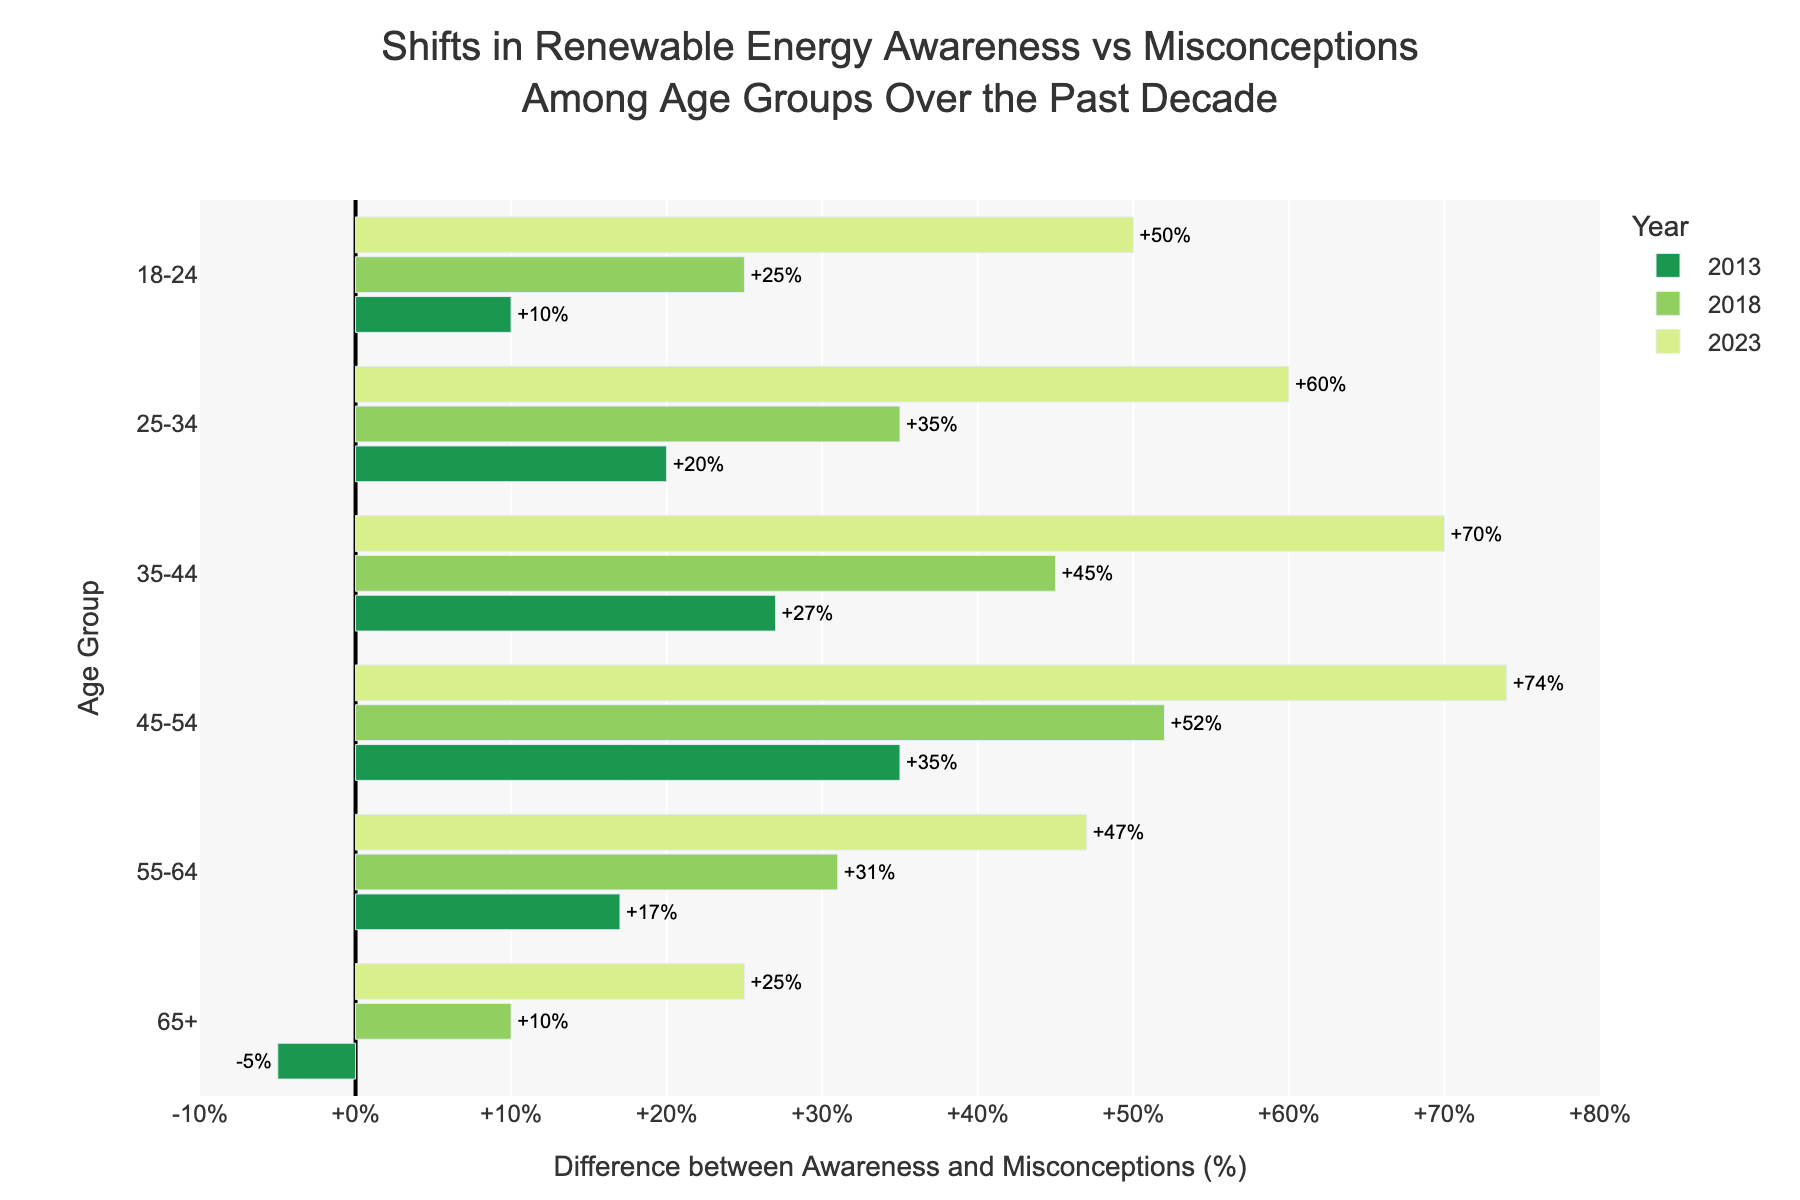What is the difference in awareness level for the age group 25-34 between 2013 and 2023? To calculate the difference in awareness level, look at the awareness levels in 2013 and 2023 for the age group 25-34. Subtract the 2013 value (50%) from the 2023 value (75%). This results in 75% - 50% = 25%.
Answer: 25% How does the misconception level for the age group 65+ change from 2013 to 2023? To see the change in the misconception level, compare the values for 2013 and 2023. In 2013, the misconception level is 45%, and in 2023 it is 30%. Calculate the difference: 45% - 30% = 15%.
Answer: Decreased by 15% Which age group saw the greatest improvement in the awareness-misconceptions difference from 2013 to 2023? Examine the difference between awareness and misconceptions for each age group in both 2013 and 2023. Calculate the improvement for each group and determine which is the greatest. For example, for age group 18-24: (70% - 20%) - (45% - 35%) = 50% - 10% = 40%. Do this for each group and compare.
Answer: 45-54 Which year had the biggest positive difference between awareness and misconceptions for the age group 35-44? Look at the difference between awareness and misconceptions for the age group 35-44 in each year. The differences are: 2013: 55% - 28% = 27%, 2018: 65% - 20% = 45%, 2023: 80% -10% = 70%. The biggest positive difference is in 2023.
Answer: 2023 Between 2013 and 2023, which age group had the least change in awareness percentage? Determine the change in awareness for each age group between 2013 and 2023. For example, for age group 18-24: 70% - 45% = 25%. Do this for each age group and find the smallest value.
Answer: 65+ For the year 2023, which age group has the smallest difference between awareness and misconceptions? Look at the 2023 data and calculate the difference between awareness and misconceptions for each age group. The differences are: 18-24 (70% - 20% = 50%), 25-34 (75% - 15% = 60%), 35-44 (80% - 10% = 70%), 45-54 (82% - 8% = 74%), 55-64 (67% - 20% = 47%), 65+ (55% - 30% = 25%). The smallest difference is for the age group 65+.
Answer: 65+ How did the overall trend of misconceptions change over time across all age groups? Observe the pattern in misconception levels for each age group from 2013 to 2023. Generally, note if the misconception levels are increasing or decreasing.
Answer: Decreased overall Looking only at the year 2018, list the age groups in ascending order of their awareness levels. For 2018, check the awareness levels: 18-24: 55%, 25-34: 60%, 35-44: 65%, 45-54: 70%, 55-64: 58%, 65+: 48%. Arrange these values in ascending order: 65+, 18-24, 55-64, 25-34, 35-44, 45-54.
Answer: 65+, 18-24, 55-64, 25-34, 35-44, 45-54 Which age group showed the most significant decrease in misconceptions from 2013 to 2023? Calculate the change in misconception levels for each age group from 2013 to 2023 and identify the greatest decrease. For example, for 18-24: 35% - 20% = 15%. Do this for each group and compare.
Answer: 45-54 What is the average difference between awareness and misconceptions for all age groups in 2023? Calculate the differences for each age group in 2023: 50% for 18-24, 60% for 25-34, 70% for 35-44, 74% for 45-54, 47% for 55-64, and 25% for 65+. Then, find the average: (50 + 60 + 70 + 74 + 47 + 25) / 6 ≈ 54.33%.
Answer: 54.33% 